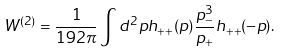Convert formula to latex. <formula><loc_0><loc_0><loc_500><loc_500>W ^ { ( 2 ) } = \frac { 1 } { 1 9 2 \pi } \int { d ^ { 2 } p h _ { + + } ( p ) \frac { p _ { - } ^ { 3 } } { p _ { + } } h _ { + + } ( - p ) } .</formula> 